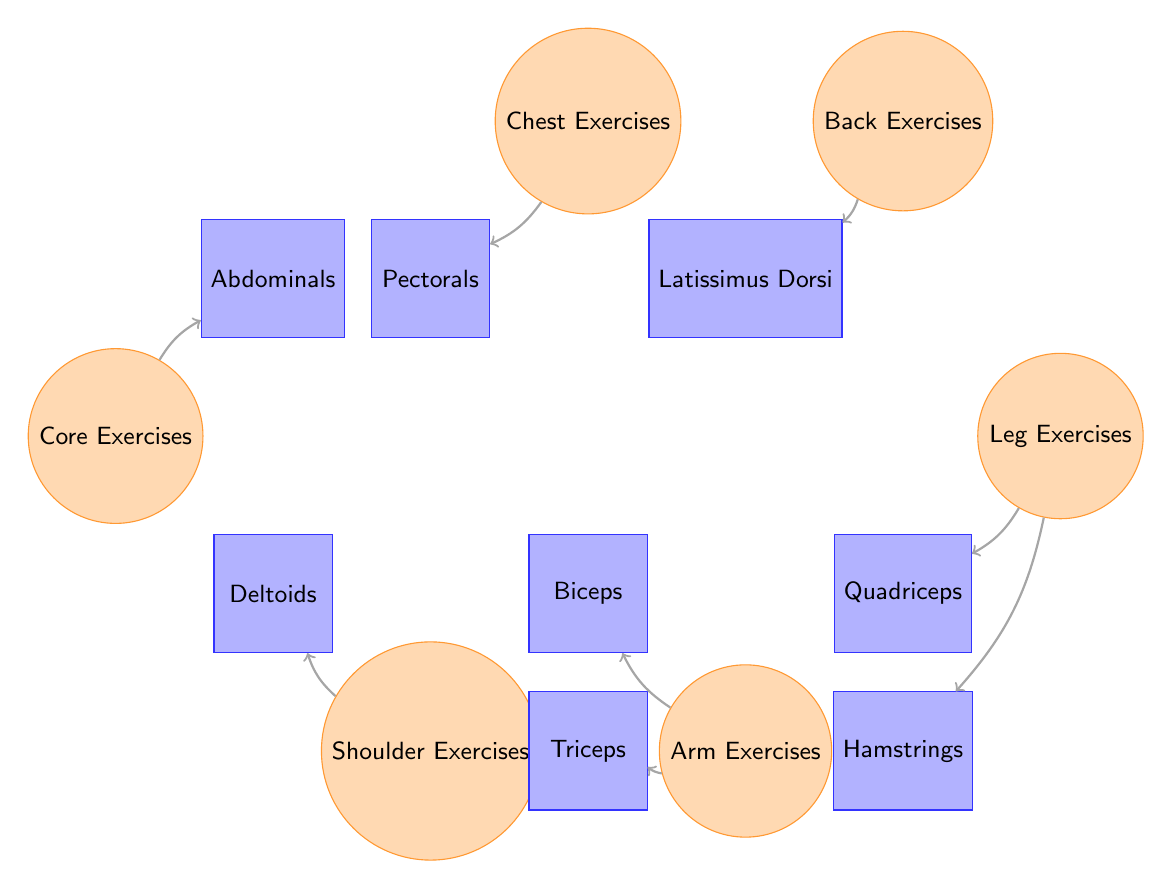What muscle group is targeted by Chest Exercises? The diagram indicates that Chest Exercises have a direct connection to the Pectorals muscle group. Therefore, the primary muscle targeted by Chest Exercises is the Pectorals.
Answer: Pectorals How many total exercise types are shown in the diagram? By counting the exercise nodes present in the diagram, we identify six unique exercise types: Chest Exercises, Back Exercises, Leg Exercises, Arm Exercises, Shoulder Exercises, and Core Exercises. Hence, the total number of exercise types is six.
Answer: 6 What muscle groups are associated with Leg Exercises? The diagram illustrates two direct connections from Leg Exercises to the muscle groups: Quadriceps and Hamstrings. Therefore, Leg Exercises target both of these muscle groups.
Answer: Quadriceps, Hamstrings Which exercise group connects to the Deltoids? According to the diagram, the connection showing which exercise group targets the Deltoids can be traced from Shoulder Exercises directly to the Deltoids muscle group. Thus, the exercise group that connects to the Deltoids is Shoulder Exercises.
Answer: Shoulder Exercises How many muscles are represented in the diagram? By counting the nodes representing muscles, we find a total of seven muscle types: Pectorals, Latissimus Dorsi, Quadriceps, Hamstrings, Biceps, Triceps, Deltoids, and Abdominals. Therefore, there are a total of eight muscles represented in the diagram.
Answer: 8 Which two exercise groups connect to Arm Exercises? The connections from Arm Exercises illustrate that they relate to two specific muscle groups: Biceps and Triceps. Therefore, the exercise groups that connect to Arm Exercises are Biceps and Triceps.
Answer: Biceps, Triceps What is the relationship between Core Exercises and Abdominals? The diagram indicates a direct connection from Core Exercises to Abdominals, signifying that Core Exercises specifically target the Abdominals muscle group. Thus, the relationship is that Core Exercises aim at the Abdominals.
Answer: Abdominals Which exercise targets the Latissimus Dorsi muscle? The Back Exercises are the exercise type that has a direct connection leading to the Latissimus Dorsi muscle, as shown in the diagram. Hence, the exercise associated with the Latissimus Dorsi is Back Exercises.
Answer: Back Exercises 